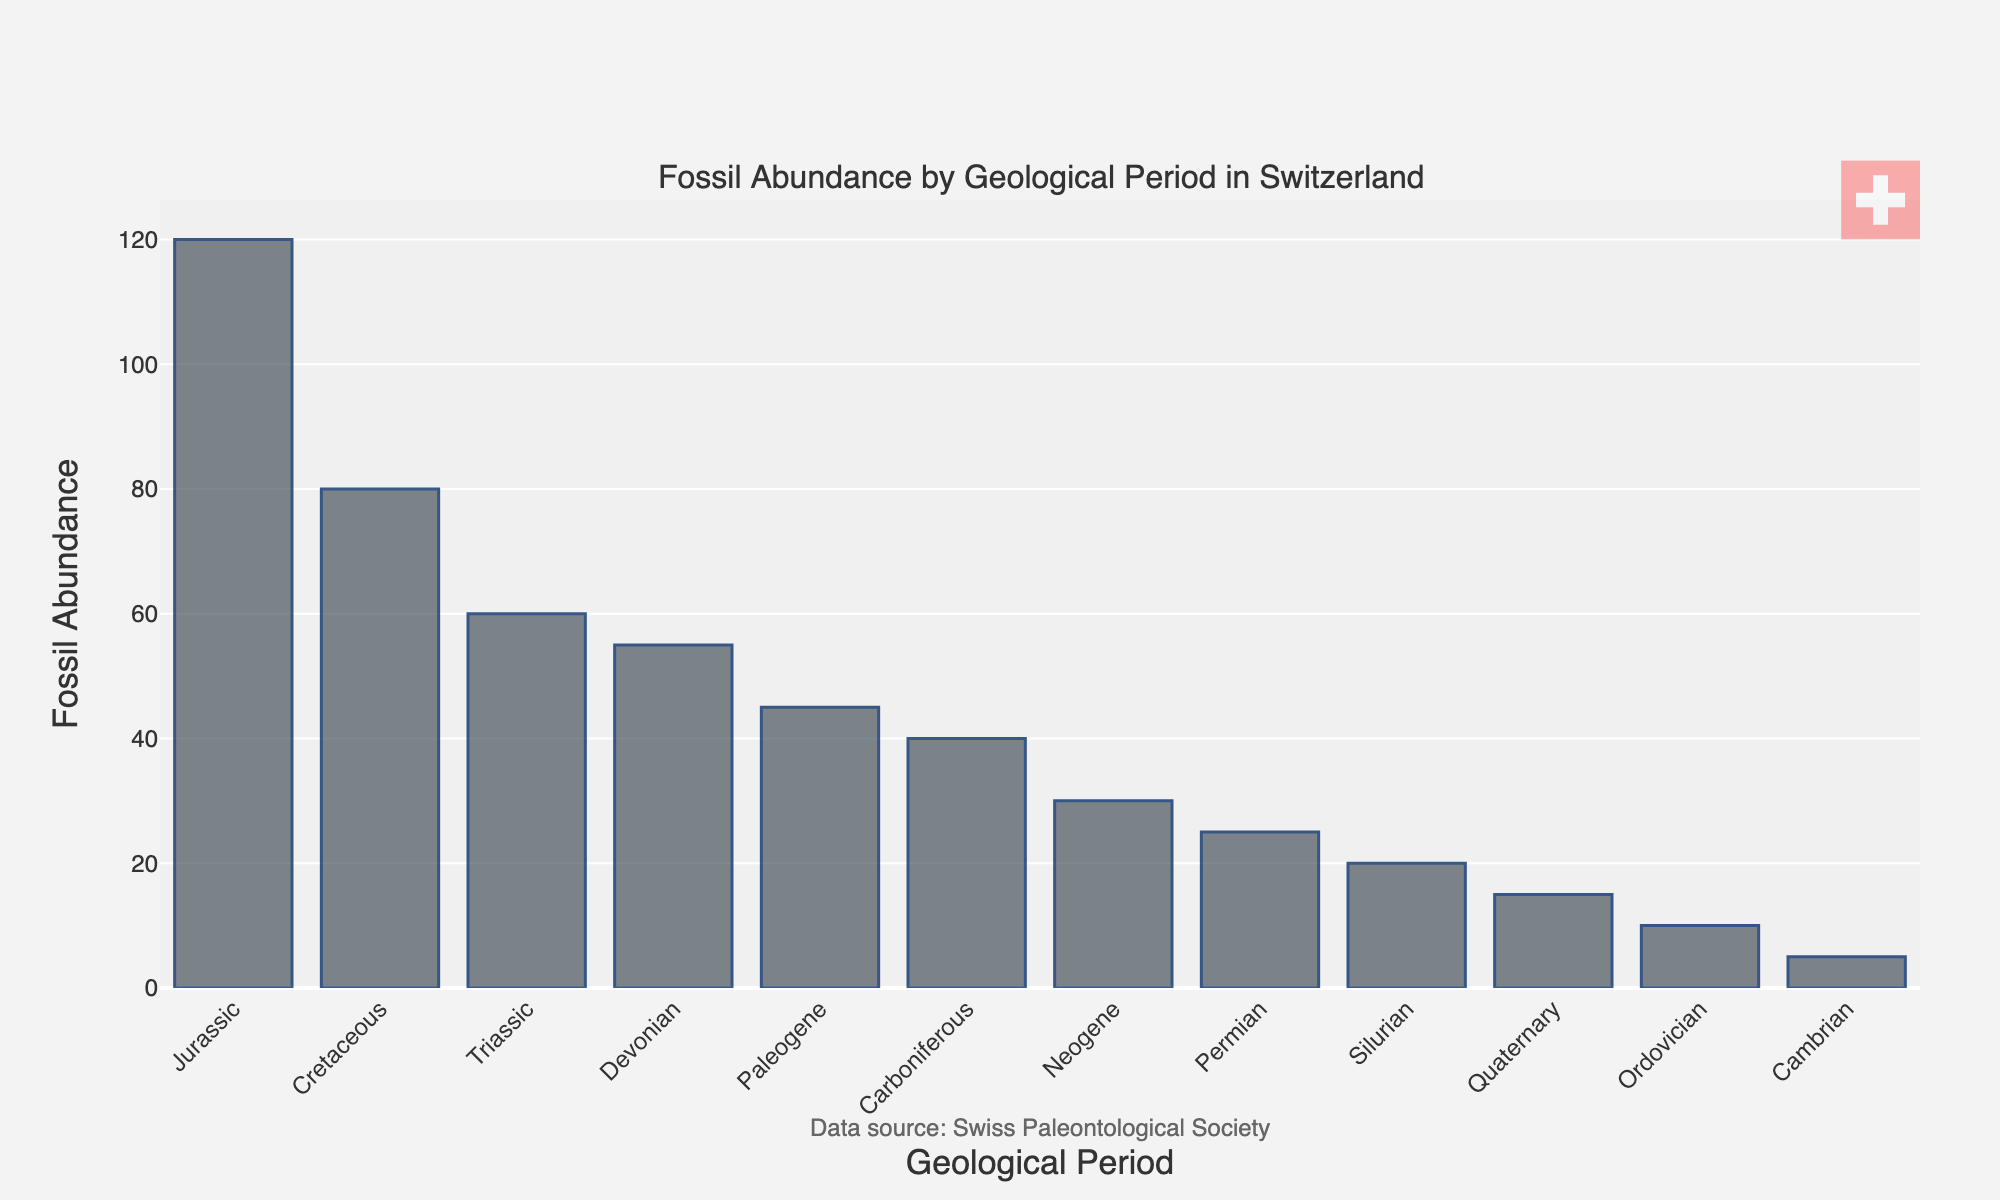Which geological period has the highest fossil abundance in Switzerland? The bar representing the Jurassic period is the tallest, indicating that it has the highest fossil abundance.
Answer: Jurassic Which geological period has the second highest fossil abundance in Switzerland? The second-tallest bar corresponds to the Cretaceous period, indicating it has the second highest fossil abundance.
Answer: Cretaceous What is the total fossil abundance for the Paleozoic era (Cambrian, Ordovician, Silurian, Devonian, Carboniferous, Permian)? Sum the fossil abundances for the Paleozoic periods: 5 (Cambrian) + 10 (Ordovician) + 20 (Silurian) + 55 (Devonian) + 40 (Carboniferous) + 25 (Permian) = 155.
Answer: 155 What is the difference in fossil abundance between the Jurassic and Triassic periods? Subtract the fossil abundance of the Triassic period from the Jurassic: 120 - 60 = 60.
Answer: 60 Which period has a fossil abundance of 55? The bar corresponding to the Devonian period represents a fossil abundance of 55.
Answer: Devonian Is the fossil abundance of the Triassic period greater than the combined fossil abundance of the Ordovician and Silurian periods? Combine the fossil abundances of the Ordovician and Silurian periods: 10 + 20 = 30. The Triassic period has a fossil abundance of 60, which is greater than 30.
Answer: Yes What is the average fossil abundance of the Mesozoic era (Triassic, Jurassic, Cretaceous)? Calculate the total abundance for the Mesozoic periods: 60 (Triassic) + 120 (Jurassic) + 80 (Cretaceous) = 260. Then, divide by the number of periods: 260 / 3 ≈ 86.67.
Answer: 86.67 Which period has the lowest fossil abundance and what is its value? The shortest bar corresponds to the Cambrian period, which has the lowest fossil abundance of 5.
Answer: Cambrian, 5 